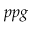<formula> <loc_0><loc_0><loc_500><loc_500>p p g</formula> 